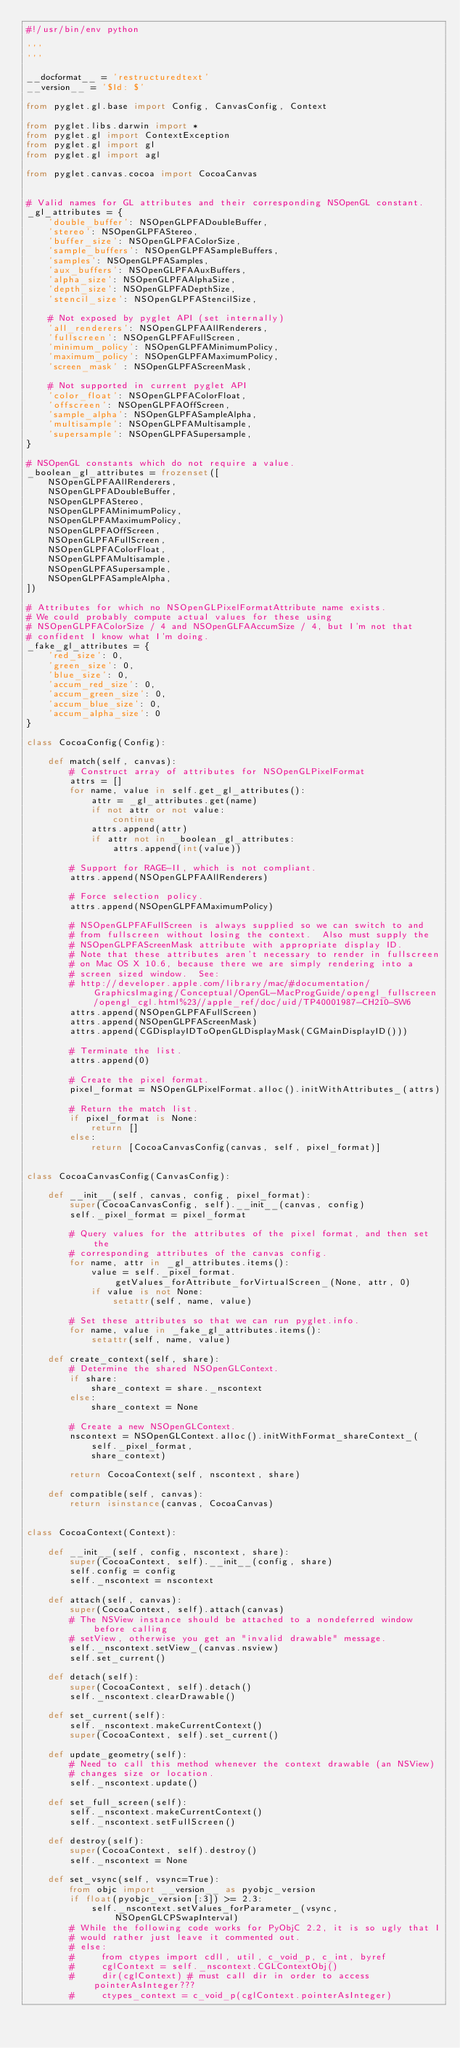<code> <loc_0><loc_0><loc_500><loc_500><_Python_>#!/usr/bin/env python

'''
'''

__docformat__ = 'restructuredtext'
__version__ = '$Id: $'

from pyglet.gl.base import Config, CanvasConfig, Context

from pyglet.libs.darwin import *
from pyglet.gl import ContextException
from pyglet.gl import gl
from pyglet.gl import agl

from pyglet.canvas.cocoa import CocoaCanvas


# Valid names for GL attributes and their corresponding NSOpenGL constant.
_gl_attributes = {
    'double_buffer': NSOpenGLPFADoubleBuffer,
    'stereo': NSOpenGLPFAStereo,
    'buffer_size': NSOpenGLPFAColorSize, 
    'sample_buffers': NSOpenGLPFASampleBuffers,
    'samples': NSOpenGLPFASamples,
    'aux_buffers': NSOpenGLPFAAuxBuffers,
    'alpha_size': NSOpenGLPFAAlphaSize,
    'depth_size': NSOpenGLPFADepthSize,
    'stencil_size': NSOpenGLPFAStencilSize,

    # Not exposed by pyglet API (set internally)
    'all_renderers': NSOpenGLPFAAllRenderers,
    'fullscreen': NSOpenGLPFAFullScreen,
    'minimum_policy': NSOpenGLPFAMinimumPolicy,
    'maximum_policy': NSOpenGLPFAMaximumPolicy,
    'screen_mask' : NSOpenGLPFAScreenMask,

    # Not supported in current pyglet API
    'color_float': NSOpenGLPFAColorFloat,
    'offscreen': NSOpenGLPFAOffScreen,
    'sample_alpha': NSOpenGLPFASampleAlpha,
    'multisample': NSOpenGLPFAMultisample,
    'supersample': NSOpenGLPFASupersample,
}

# NSOpenGL constants which do not require a value.
_boolean_gl_attributes = frozenset([
    NSOpenGLPFAAllRenderers, 
    NSOpenGLPFADoubleBuffer,
    NSOpenGLPFAStereo,
    NSOpenGLPFAMinimumPolicy,
    NSOpenGLPFAMaximumPolicy,
    NSOpenGLPFAOffScreen,
    NSOpenGLPFAFullScreen,
    NSOpenGLPFAColorFloat,
    NSOpenGLPFAMultisample,
    NSOpenGLPFASupersample,
    NSOpenGLPFASampleAlpha,
])

# Attributes for which no NSOpenGLPixelFormatAttribute name exists.
# We could probably compute actual values for these using 
# NSOpenGLPFAColorSize / 4 and NSOpenGLFAAccumSize / 4, but I'm not that 
# confident I know what I'm doing.
_fake_gl_attributes = {
    'red_size': 0,
    'green_size': 0,
    'blue_size': 0,
    'accum_red_size': 0,
    'accum_green_size': 0,
    'accum_blue_size': 0,
    'accum_alpha_size': 0
}

class CocoaConfig(Config):

    def match(self, canvas):
        # Construct array of attributes for NSOpenGLPixelFormat
        attrs = []
        for name, value in self.get_gl_attributes():
            attr = _gl_attributes.get(name)
            if not attr or not value:
                continue
            attrs.append(attr)
            if attr not in _boolean_gl_attributes:
                attrs.append(int(value))

        # Support for RAGE-II, which is not compliant.
        attrs.append(NSOpenGLPFAAllRenderers)

        # Force selection policy.
        attrs.append(NSOpenGLPFAMaximumPolicy)

        # NSOpenGLPFAFullScreen is always supplied so we can switch to and
        # from fullscreen without losing the context.  Also must supply the
        # NSOpenGLPFAScreenMask attribute with appropriate display ID.
        # Note that these attributes aren't necessary to render in fullscreen
        # on Mac OS X 10.6, because there we are simply rendering into a 
        # screen sized window.  See:
        # http://developer.apple.com/library/mac/#documentation/GraphicsImaging/Conceptual/OpenGL-MacProgGuide/opengl_fullscreen/opengl_cgl.html%23//apple_ref/doc/uid/TP40001987-CH210-SW6
        attrs.append(NSOpenGLPFAFullScreen)
        attrs.append(NSOpenGLPFAScreenMask)
        attrs.append(CGDisplayIDToOpenGLDisplayMask(CGMainDisplayID()))
        
        # Terminate the list.
        attrs.append(0)

        # Create the pixel format.
        pixel_format = NSOpenGLPixelFormat.alloc().initWithAttributes_(attrs)
                
        # Return the match list.
        if pixel_format is None:
            return []
        else:
            return [CocoaCanvasConfig(canvas, self, pixel_format)]


class CocoaCanvasConfig(CanvasConfig):

    def __init__(self, canvas, config, pixel_format):
        super(CocoaCanvasConfig, self).__init__(canvas, config)
        self._pixel_format = pixel_format

        # Query values for the attributes of the pixel format, and then set the
        # corresponding attributes of the canvas config.
        for name, attr in _gl_attributes.items():
            value = self._pixel_format.getValues_forAttribute_forVirtualScreen_(None, attr, 0)
            if value is not None:
                setattr(self, name, value)
        
        # Set these attributes so that we can run pyglet.info.
        for name, value in _fake_gl_attributes.items():
            setattr(self, name, value)
 
    def create_context(self, share):
        # Determine the shared NSOpenGLContext.
        if share:
            share_context = share._nscontext
        else:
            share_context = None

        # Create a new NSOpenGLContext.
        nscontext = NSOpenGLContext.alloc().initWithFormat_shareContext_(
            self._pixel_format,
            share_context)

        return CocoaContext(self, nscontext, share)

    def compatible(self, canvas):
        return isinstance(canvas, CocoaCanvas)


class CocoaContext(Context):

    def __init__(self, config, nscontext, share):
        super(CocoaContext, self).__init__(config, share)
        self.config = config
        self._nscontext = nscontext

    def attach(self, canvas):
        super(CocoaContext, self).attach(canvas)
        # The NSView instance should be attached to a nondeferred window before calling
        # setView, otherwise you get an "invalid drawable" message.
        self._nscontext.setView_(canvas.nsview)
        self.set_current()

    def detach(self):
        super(CocoaContext, self).detach()
        self._nscontext.clearDrawable()

    def set_current(self):
        self._nscontext.makeCurrentContext()
        super(CocoaContext, self).set_current()

    def update_geometry(self):
        # Need to call this method whenever the context drawable (an NSView)
        # changes size or location.
        self._nscontext.update()

    def set_full_screen(self):
        self._nscontext.makeCurrentContext()
        self._nscontext.setFullScreen()

    def destroy(self):
        super(CocoaContext, self).destroy()
        self._nscontext = None

    def set_vsync(self, vsync=True):
        from objc import __version__ as pyobjc_version
        if float(pyobjc_version[:3]) >= 2.3:
            self._nscontext.setValues_forParameter_(vsync, NSOpenGLCPSwapInterval)
        # While the following code works for PyObjC 2.2, it is so ugly that I
        # would rather just leave it commented out.
        # else:
        #     from ctypes import cdll, util, c_void_p, c_int, byref
        #     cglContext = self._nscontext.CGLContextObj()
        #     dir(cglContext) # must call dir in order to access pointerAsInteger???
        #     ctypes_context = c_void_p(cglContext.pointerAsInteger)</code> 